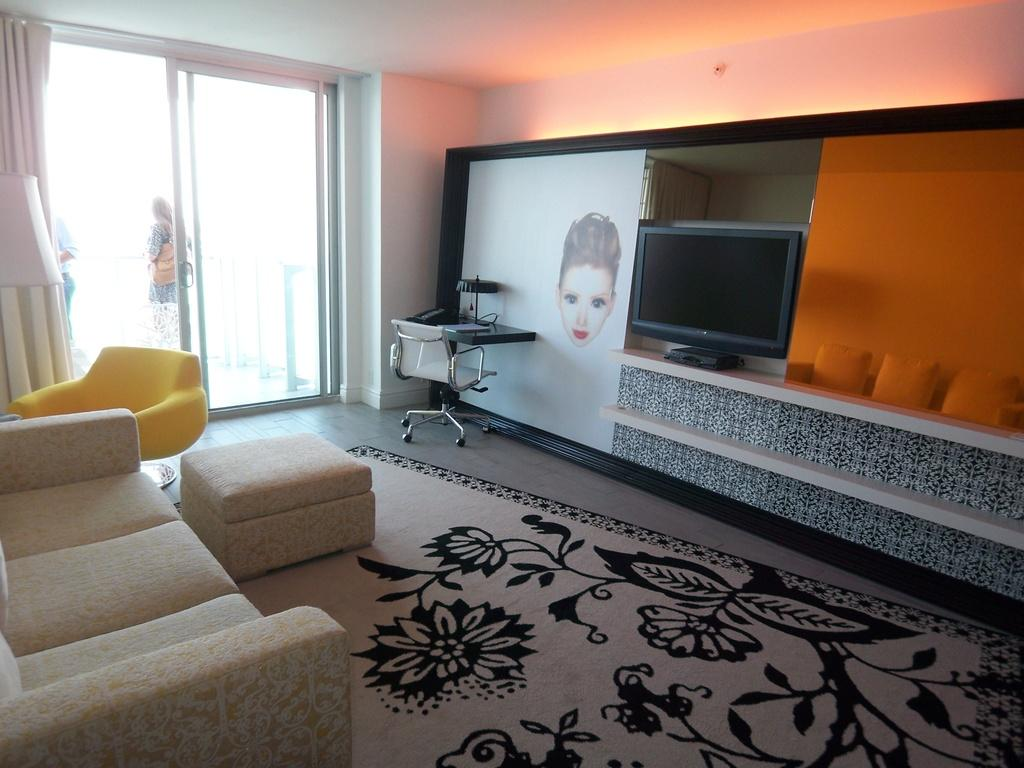What type of space is depicted in the image? There is a room in the image. What type of furniture is present in the room? There is a sofa and chairs in the room. What is on the table in the room? There is a table with lamps on it in the room. What type of entertainment device is in the room? There is a television in the room. What type of window treatment is present in the room? There is a window with curtains in the room. What type of decorative items are in the room? There are pillows in the room. How many frogs can be seen in the image? There are no frogs present in the image. What type of land is visible through the window in the image? The image does not show the view through the window, so it is not possible to determine the type of land visible. 